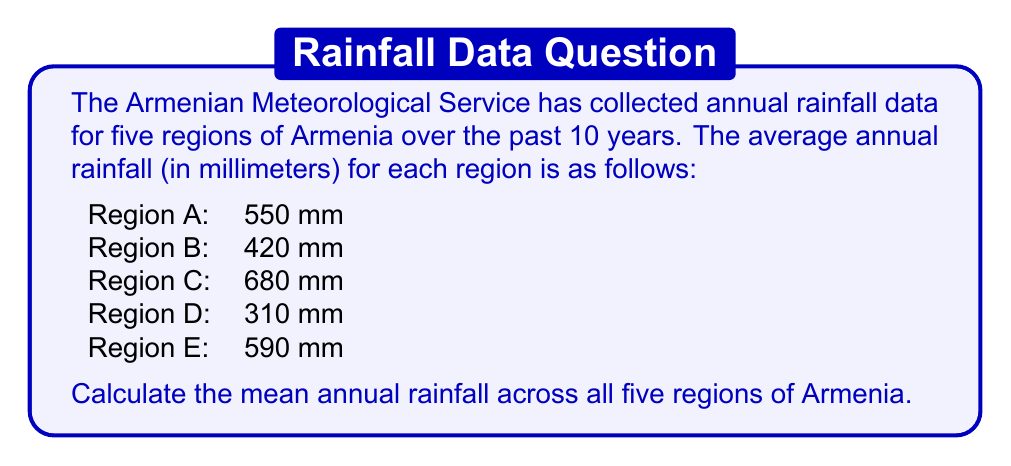Could you help me with this problem? To calculate the mean annual rainfall across all five regions, we need to:

1. Sum up the average annual rainfall for all regions:
   $$ 550 + 420 + 680 + 310 + 590 = 2550 \text{ mm} $$

2. Divide the sum by the number of regions (5):
   $$ \text{Mean} = \frac{\sum \text{Rainfall}}{\text{Number of Regions}} = \frac{2550}{5} = 510 \text{ mm} $$

Therefore, the mean annual rainfall across all five regions of Armenia is 510 mm.
Answer: 510 mm 